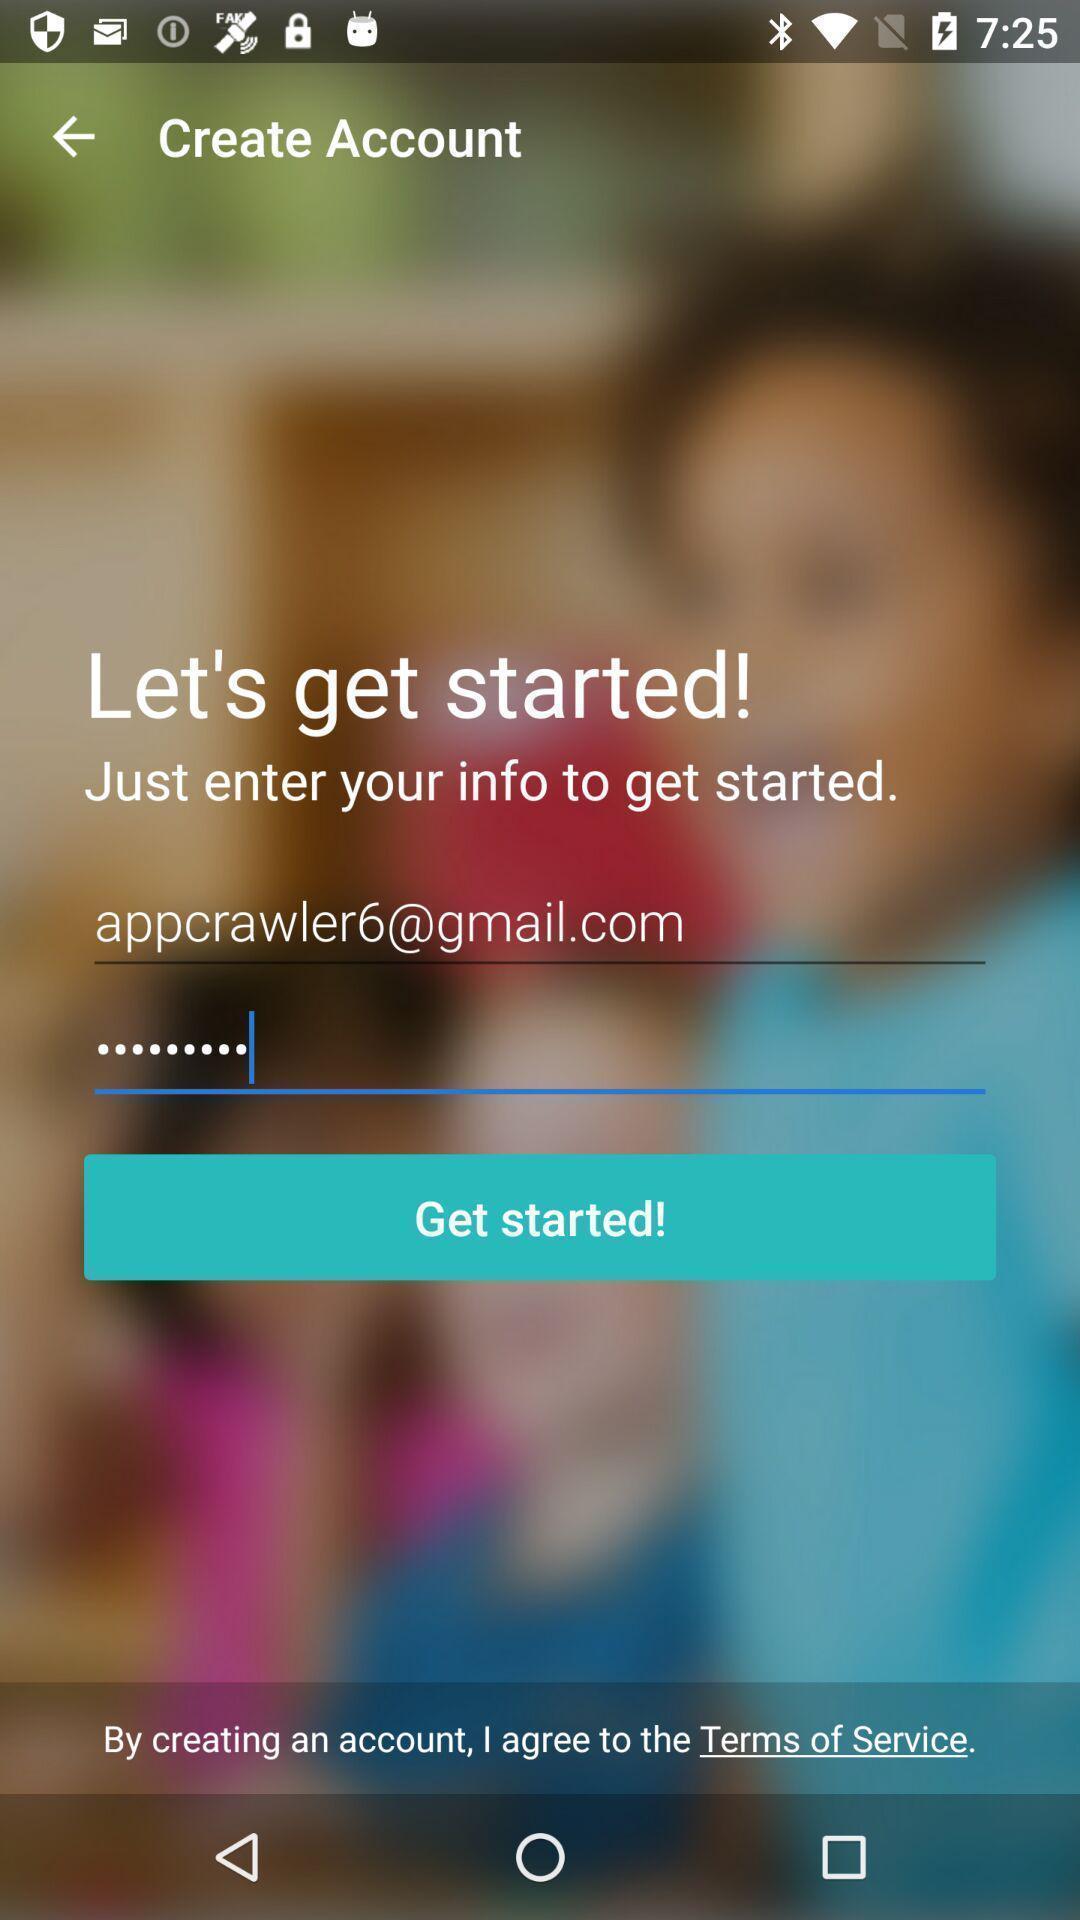Summarize the information in this screenshot. Welcome to the sign in page. 